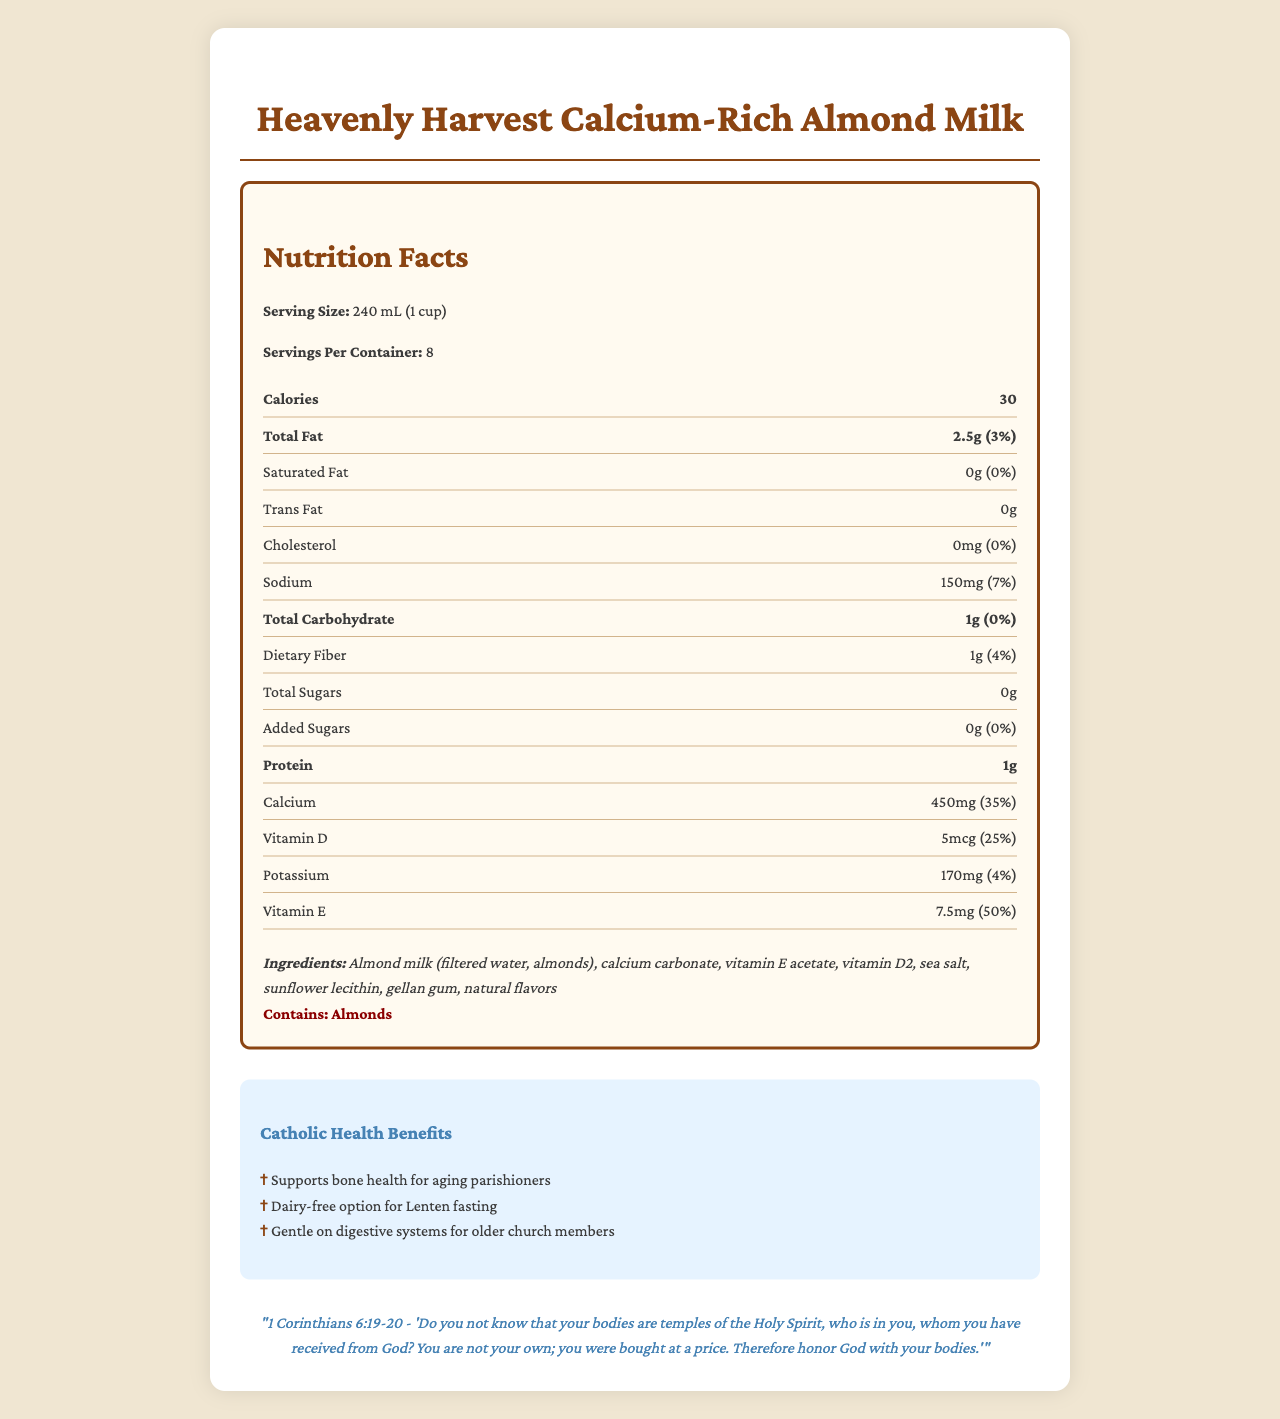what is the serving size of the almond milk? The serving size is explicitly mentioned as "240 mL (1 cup)" in the Nutrition Facts section.
Answer: 240 mL (1 cup) how much sodium is in one serving? The document states that each serving contains 150mg of sodium.
Answer: 150mg how many servings are in the container? The document mentions there are 8 servings per container.
Answer: 8 how much calcium is in one serving? The document lists the amount of calcium as 450mg per serving.
Answer: 450mg what are the main ingredients of the almond milk? The main ingredients are listed in the Ingredients section.
Answer: Almond milk (filtered water, almonds), calcium carbonate, vitamin E acetate, vitamin D2, sea salt, sunflower lecithin, gellan gum, natural flavors which vitamin is present in the highest percentage of the daily value? (A) Vitamin D (B) Vitamin E (C) Calcium (D) Potassium The percentage daily values of the vitamins are compared: Vitamin D - 25%, Vitamin E - 50%, Calcium - 35%, Potassium - 4%. Vitamin E is the highest.
Answer: (B) Vitamin E how many grams of total carbohydrates are in one serving? (i) 2g (ii) 1g (iii) 0g (iv) 4g The document notes that the total carbohydrates amount to 1g per serving.
Answer: (ii) 1g does the almond milk contain any added sugars? The Nutrition Facts state that there are 0g of added sugars.
Answer: No is this a suitable option for those who are lactose intolerant? The document highlights it as a dairy-free option, which makes it suitable for those who are lactose intolerant.
Answer: Yes summarize the main benefits and nutrients of this Calcium-Rich Almond Milk. The summary combines information from the Nutrition Facts, Catholic Health Benefits, and general description sections, giving a holistic view of the main benefits and nutrients of the product.
Answer: This almond milk by Heavenly Harvest is a low-calorie, dairy-free beverage that supports bone health with 450mg of calcium and 5mcg of vitamin D per serving. It offers essential nutrients like vitamin E, is gentle on digestive systems, and contains no cholesterol or added sugars, making it ideal for health-conscious individuals and suitable for Lenten fasting. how does this product help aging parishioners? The Catholic Health Benefits section specifically mentions bone health for aging parishioners, supported by the nutrient details in the Nutrition Facts.
Answer: It supports bone health with a high calcium content of 450mg per serving and vitamin D, which are crucial for maintaining strong bones. what does the Bible verse on the document say? The document quotes 1 Corinthians 6:19-20 and provides the verse about honoring the body as a temple of the Holy Spirit.
Answer: "Do you not know that your bodies are temples of the Holy Spirit, who is in you, whom you have received from God? You are not your own; you were bought at a price. Therefore honor God with your bodies." - 1 Corinthians 6:19-20 how many calories are in one serving of the almond milk? The document states that there are 30 calories per serving.
Answer: 30 does the almond milk contain any cholesterol? The Nutrition Facts section specifies that the cholesterol content is 0mg.
Answer: No how many grams of protein are in one serving of almond milk? The document clearly lists the protein content as 1g per serving.
Answer: 1g which nutrient amount cannot be verified from the document? The document does not list any amount or daily value percentage for Vitamin C.
Answer: Vitamin C do you have to refrigerate the almond milk after opening? The provided document does not contain any information about storage instructions or refrigeration.
Answer: Not enough information 